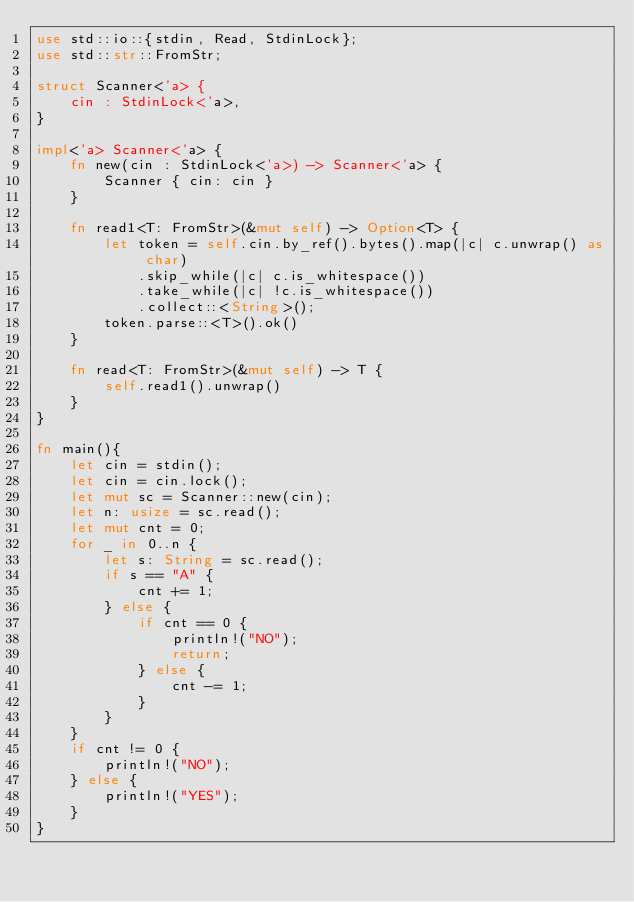<code> <loc_0><loc_0><loc_500><loc_500><_Rust_>use std::io::{stdin, Read, StdinLock};
use std::str::FromStr;

struct Scanner<'a> {
    cin : StdinLock<'a>,
}

impl<'a> Scanner<'a> {
    fn new(cin : StdinLock<'a>) -> Scanner<'a> {
        Scanner { cin: cin }
    }

    fn read1<T: FromStr>(&mut self) -> Option<T> {
        let token = self.cin.by_ref().bytes().map(|c| c.unwrap() as char)
            .skip_while(|c| c.is_whitespace())
            .take_while(|c| !c.is_whitespace())
            .collect::<String>();
        token.parse::<T>().ok()
    }

    fn read<T: FromStr>(&mut self) -> T {
        self.read1().unwrap()
    }
}

fn main(){
    let cin = stdin();
    let cin = cin.lock();
    let mut sc = Scanner::new(cin);
    let n: usize = sc.read();
    let mut cnt = 0;
    for _ in 0..n {
        let s: String = sc.read();
        if s == "A" {
            cnt += 1;
        } else {
            if cnt == 0 {
                println!("NO");
                return;
            } else {
                cnt -= 1;
            }
        }
    }
    if cnt != 0 {
        println!("NO");
    } else {
        println!("YES");
    }
}

</code> 